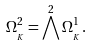<formula> <loc_0><loc_0><loc_500><loc_500>\Omega ^ { 2 } _ { \AA _ { K } } = \bigwedge ^ { 2 } \Omega ^ { 1 } _ { \AA _ { K } } .</formula> 